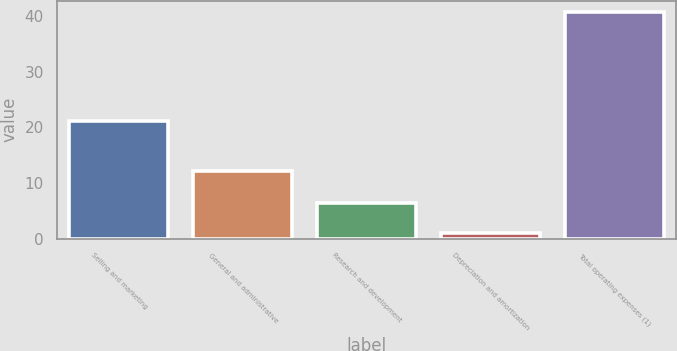Convert chart. <chart><loc_0><loc_0><loc_500><loc_500><bar_chart><fcel>Selling and marketing<fcel>General and administrative<fcel>Research and development<fcel>Depreciation and amortization<fcel>Total operating expenses (1)<nl><fcel>21.2<fcel>12.1<fcel>6.4<fcel>1<fcel>40.7<nl></chart> 